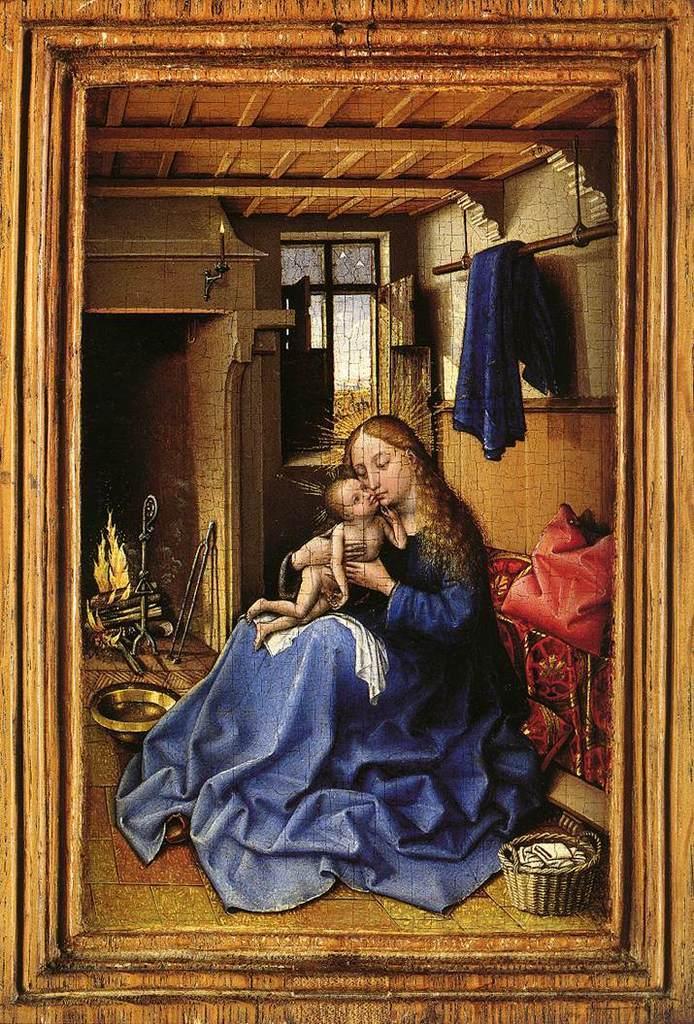How would you summarize this image in a sentence or two? In this image there is painting, in that painting there is a lady holding a baby in her hands, in the background there is a fire pit, window, at the top the is a wooden ceiling and a cloth. 